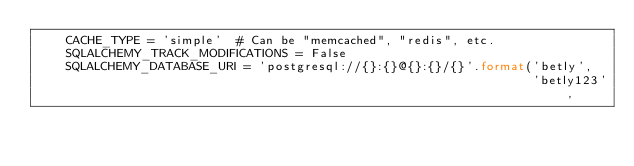Convert code to text. <code><loc_0><loc_0><loc_500><loc_500><_Python_>    CACHE_TYPE = 'simple'  # Can be "memcached", "redis", etc.
    SQLALCHEMY_TRACK_MODIFICATIONS = False
    SQLALCHEMY_DATABASE_URI = 'postgresql://{}:{}@{}:{}/{}'.format('betly',
                                                                   'betly123',</code> 